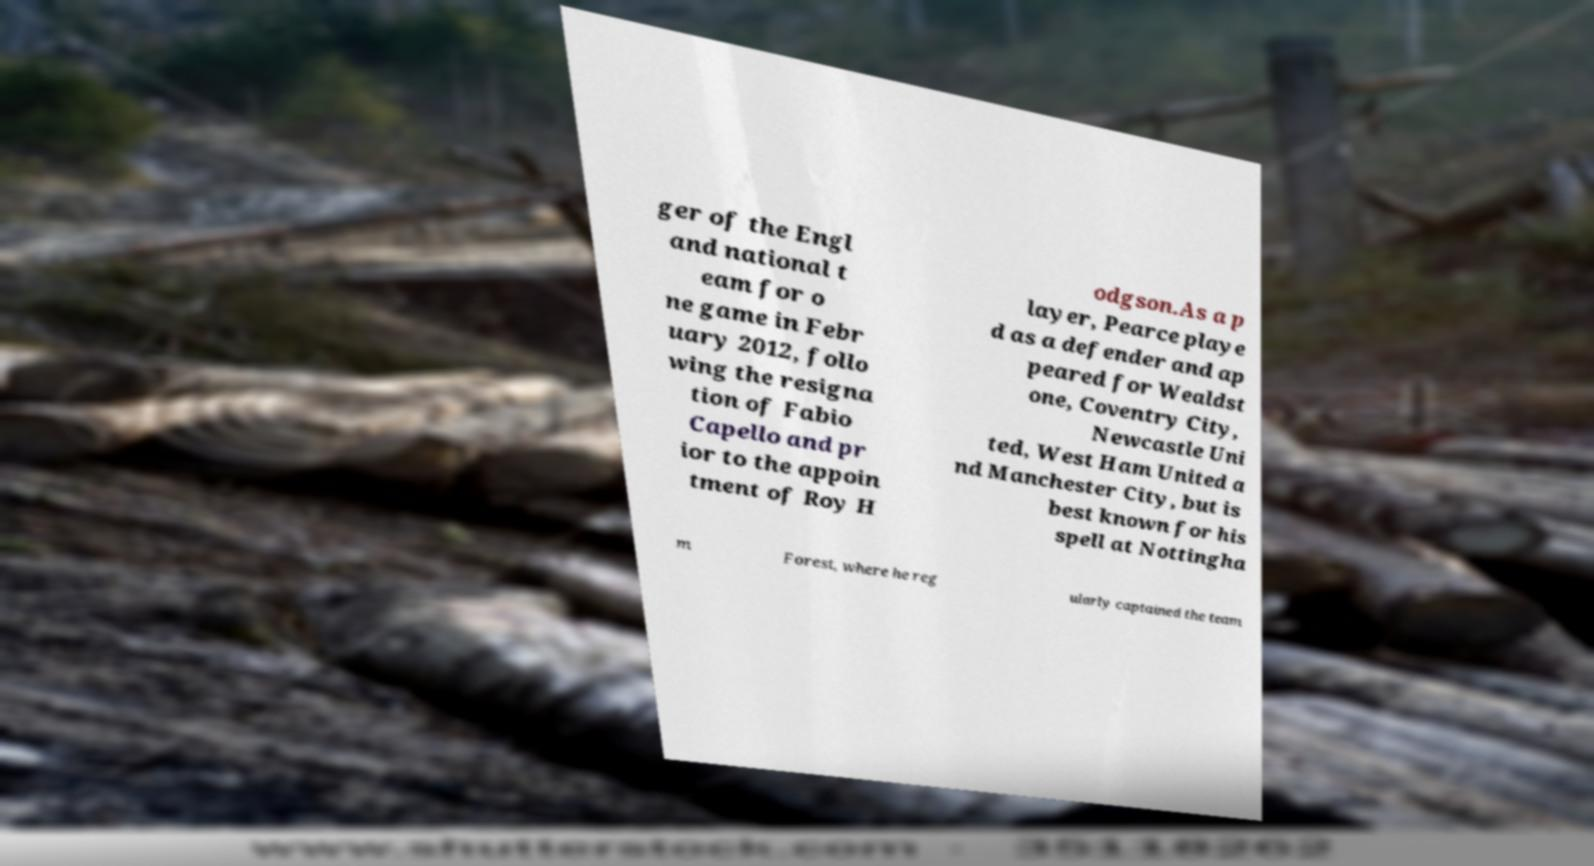Could you extract and type out the text from this image? ger of the Engl and national t eam for o ne game in Febr uary 2012, follo wing the resigna tion of Fabio Capello and pr ior to the appoin tment of Roy H odgson.As a p layer, Pearce playe d as a defender and ap peared for Wealdst one, Coventry City, Newcastle Uni ted, West Ham United a nd Manchester City, but is best known for his spell at Nottingha m Forest, where he reg ularly captained the team 